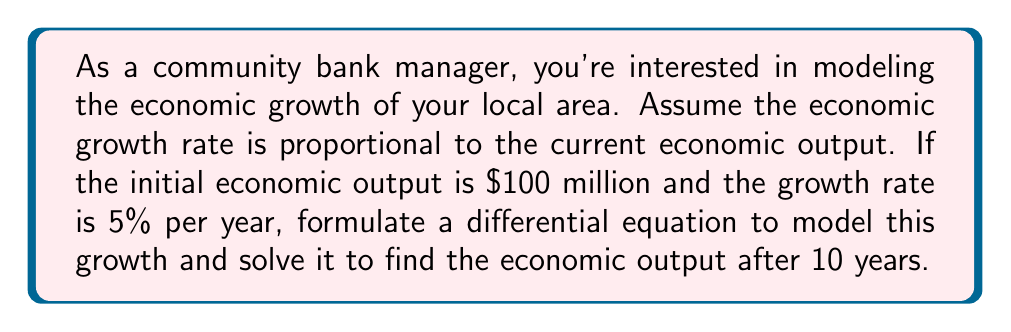Provide a solution to this math problem. Let's approach this step-by-step:

1) Let $P(t)$ be the economic output at time $t$ in years.

2) The given information states that the growth rate is proportional to the current output. This can be expressed mathematically as:

   $$\frac{dP}{dt} = kP$$

   where $k$ is the growth rate constant.

3) We're given that the growth rate is 5% per year, so $k = 0.05$.

4) The initial condition is $P(0) = 100$ million.

5) Now we have the complete initial value problem:

   $$\frac{dP}{dt} = 0.05P, \quad P(0) = 100$$

6) To solve this, we can separate variables:

   $$\frac{dP}{P} = 0.05dt$$

7) Integrating both sides:

   $$\int \frac{dP}{P} = \int 0.05dt$$
   $$\ln|P| = 0.05t + C$$

8) Applying the initial condition:

   $$\ln|100| = 0.05(0) + C$$
   $$C = \ln|100| = 4.60517$$

9) Therefore, the general solution is:

   $$\ln|P| = 0.05t + 4.60517$$
   $$P(t) = e^{0.05t + 4.60517} = 100e^{0.05t}$$

10) To find the output after 10 years, we evaluate $P(10)$:

    $$P(10) = 100e^{0.05(10)} = 100e^{0.5} \approx 164.87$$

Therefore, after 10 years, the economic output will be approximately $164.87 million.
Answer: $164.87 million 